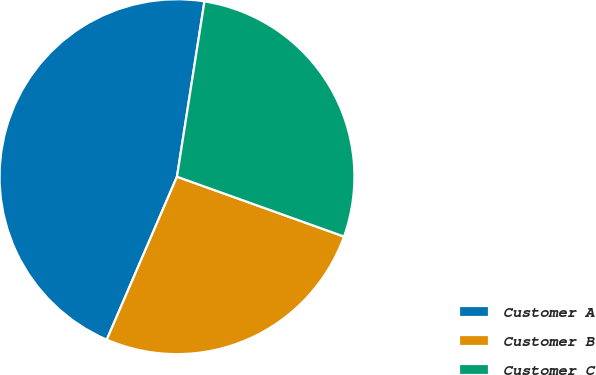Convert chart. <chart><loc_0><loc_0><loc_500><loc_500><pie_chart><fcel>Customer A<fcel>Customer B<fcel>Customer C<nl><fcel>46.0%<fcel>26.0%<fcel>28.0%<nl></chart> 